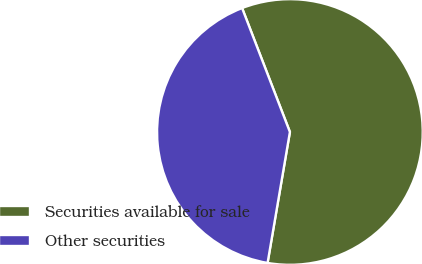<chart> <loc_0><loc_0><loc_500><loc_500><pie_chart><fcel>Securities available for sale<fcel>Other securities<nl><fcel>58.55%<fcel>41.45%<nl></chart> 